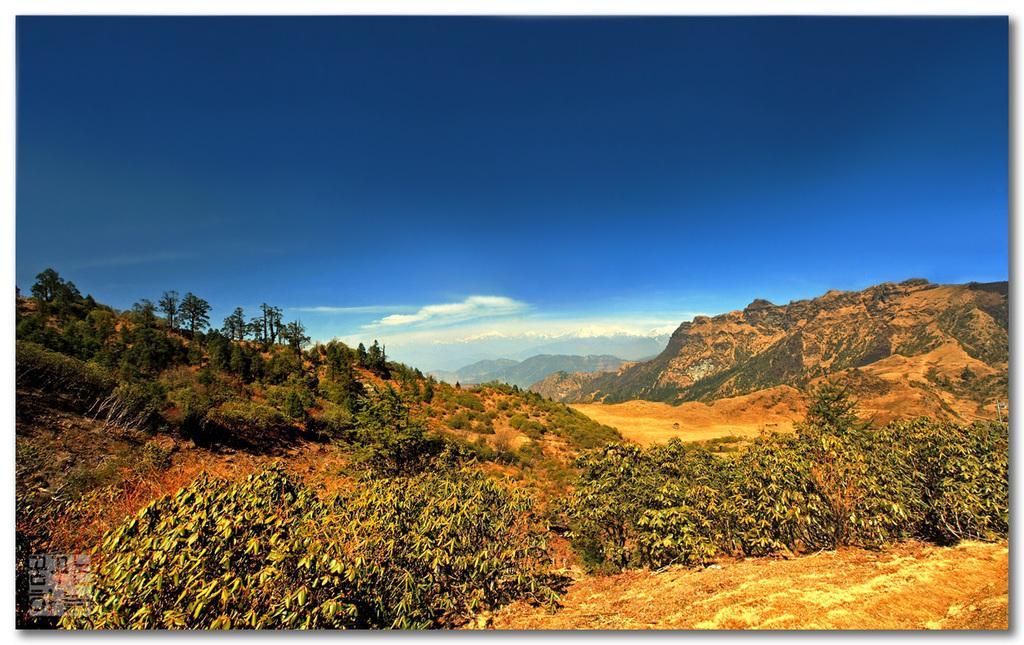Describe this image in one or two sentences. In this image, we can see some trees and plants. There are hills in the middle of the image. There are clouds in the sky. 